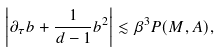<formula> <loc_0><loc_0><loc_500><loc_500>\left | \partial _ { \tau } b + \frac { 1 } { d - 1 } b ^ { 2 } \right | & \lesssim \beta ^ { 3 } P ( M , A ) ,</formula> 